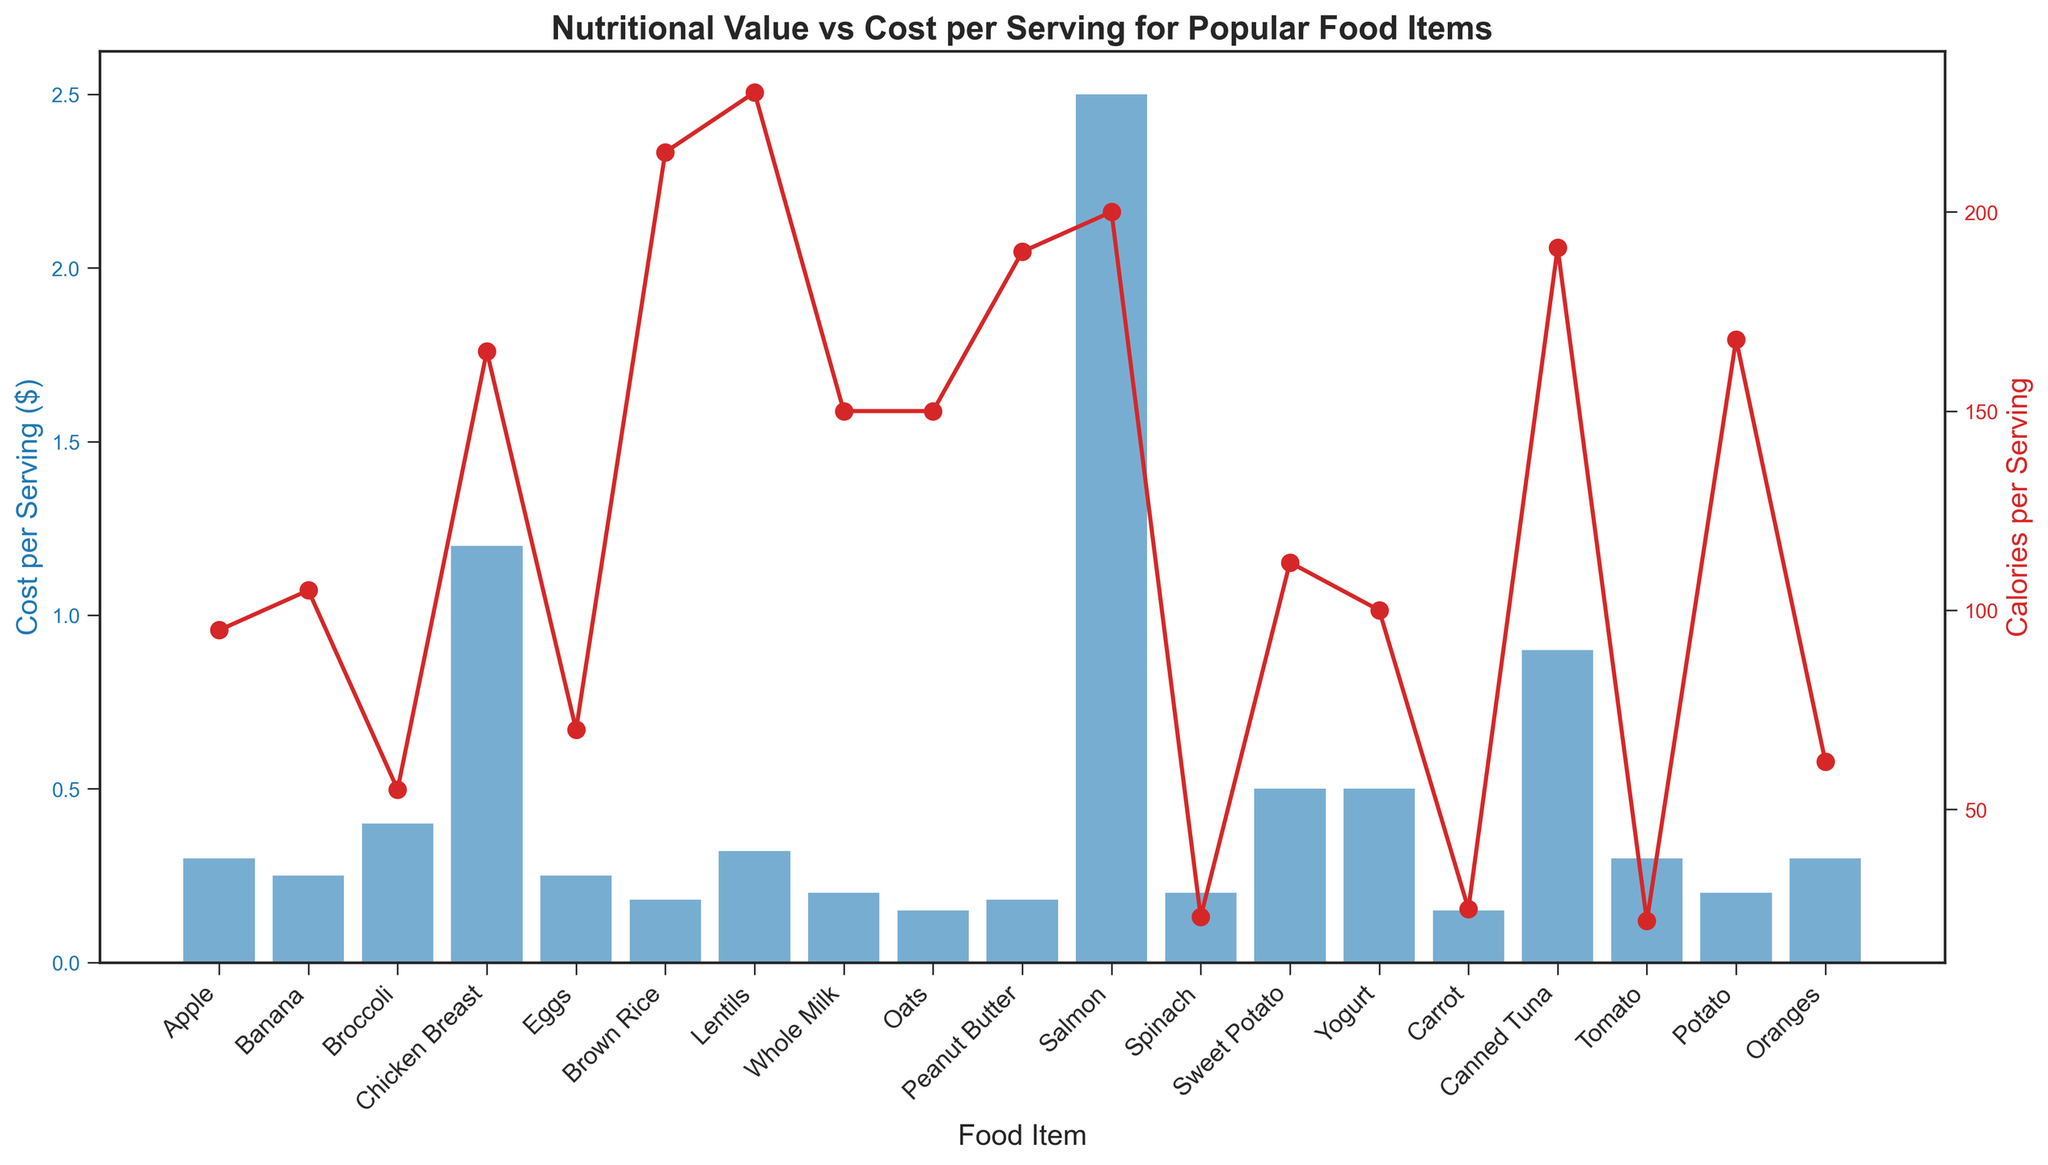What's the most expensive food item? The bars represent the cost per serving. By observing the heights, we can see that the tallest blue bar corresponds to ‘Salmon’. Thus, it is the most expensive food item.
Answer: Salmon Which food item provides the most calories per serving, and what is the cost of that item? The red lines represent the calories per serving. The highest point on the red line corresponds to ‘Lentils’ with 230 calories. The blue bar below this point shows a cost of $0.32.
Answer: Lentils, $0.32 Which food item is both low in cost and low in calories? For low cost and low calories, we need to look for a shorter blue bar and a lower point on the red line. 'Carrot' has both a low cost (0.15) and low calories (25).
Answer: Carrot What's the cost difference between the most and the least expensive items? The most expensive item is ‘Salmon’ at $2.5, and the least expensive is ‘Oats’ and ‘Carrot’ at $0.15. The difference is $2.5 - $0.15 = $2.35.
Answer: $2.35 Which food item has a higher cost per serving: 'Broccoli' or 'Chicken Breast'? By how much? Comparing the bars for ‘Broccoli’ and ‘Chicken Breast’, the blue bar for ‘Chicken Breast’ is higher than ‘Broccoli’. The cost for 'Chicken Breast' is $1.2, and for 'Broccoli', it is $0.4. The difference is $1.2 - $0.4 = $0.8.
Answer: Chicken Breast, $0.8 How does the cost per serving of 'Eggs' compare to that of 'Banana'? The cost per serving of ‘Eggs’ and ‘Banana’ can be compared by looking at their respective blue bars. They are both equal in height, indicating that both cost $0.25.
Answer: They are equal Which food item has the highest cost per serving but provides fewer than 100 calories per serving? Looking for the food items with fewer than 100 calories (points below the 100-calorie line), 'Tomato', 'Spinach', and 'Carrot' qualify. The one with the highest blue bar among these is 'Spinach' at $0.2.
Answer: Spinach What is the average cost per serving for the items 'Tomato', 'Potato', and 'Oranges'? The cost for 'Tomato', 'Potato', and 'Oranges' are $0.3, $0.2, and $0.3, respectively. The average cost per serving is calculated as (0.3 + 0.2 + 0.3) / 3 = 0.8 / 3 ≈ $0.27.
Answer: $0.27 Between 'Apple' and 'Oranges', which has a higher caloric content per serving, and by how much? By comparing the red line markers for 'Apple' and 'Oranges', ‘Apple’ has 95 calories, and ‘Oranges’ has 62 calories. The difference is 95 - 62 = 33 calories.
Answer: Apple, 33 calories Which food items have a cost per serving of exactly $0.2? By scanning the blue bars at the $0.2 height mark, the food items are 'Whole Milk', 'Spinach', and 'Potato'.
Answer: Whole Milk, Spinach, Potato 